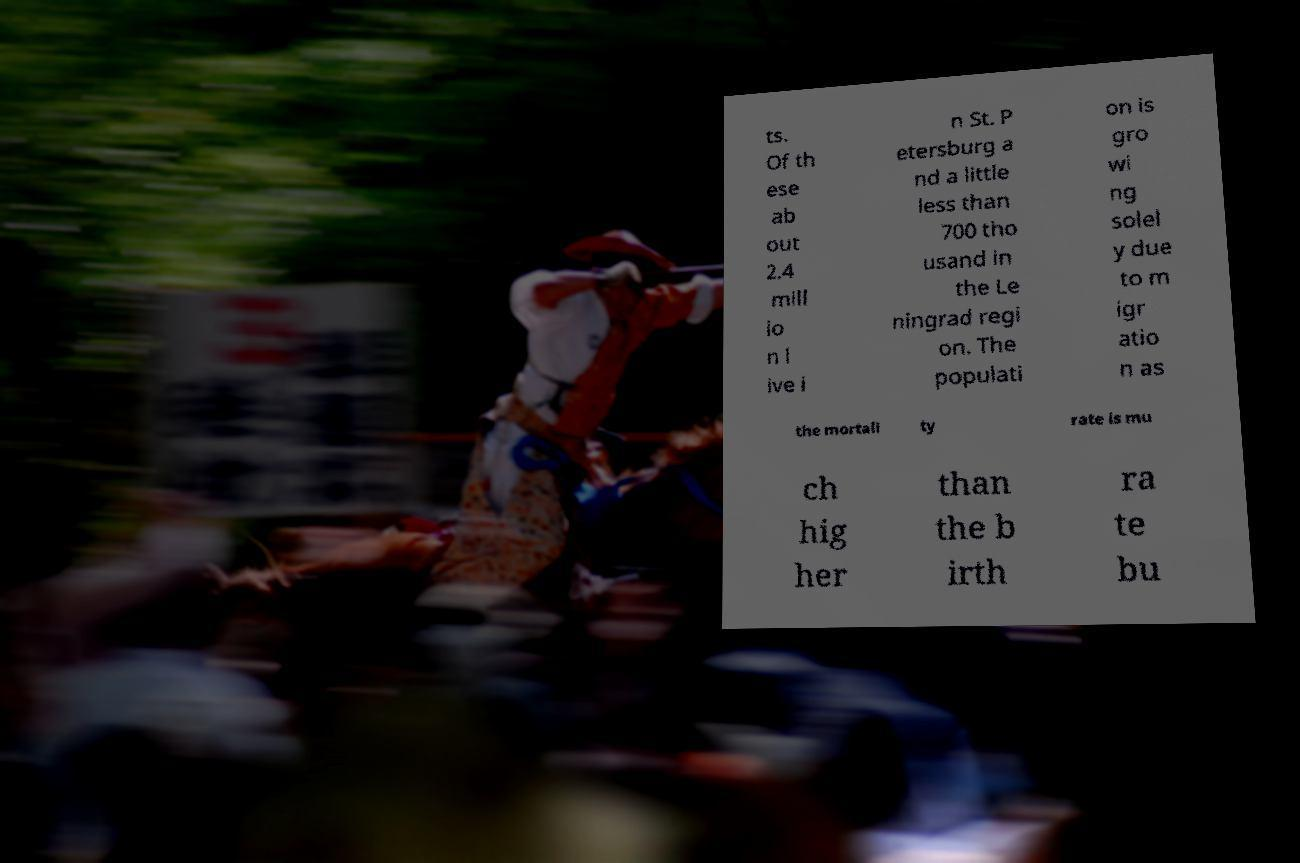Please read and relay the text visible in this image. What does it say? ts. Of th ese ab out 2.4 mill io n l ive i n St. P etersburg a nd a little less than 700 tho usand in the Le ningrad regi on. The populati on is gro wi ng solel y due to m igr atio n as the mortali ty rate is mu ch hig her than the b irth ra te bu 